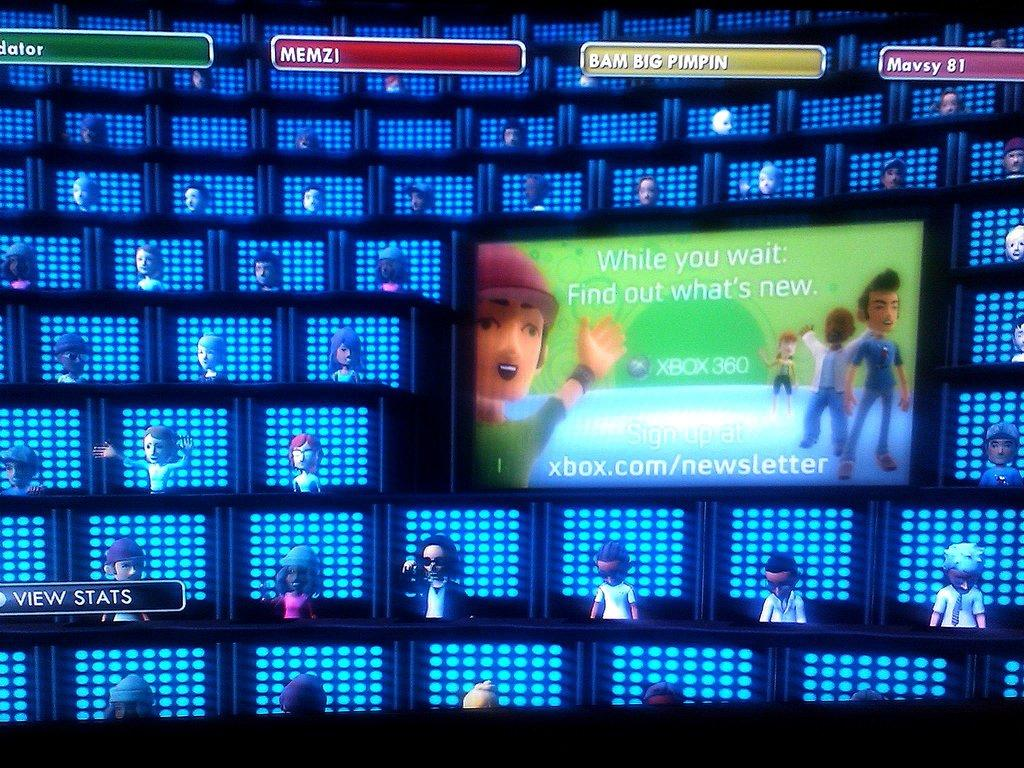<image>
Offer a succinct explanation of the picture presented. Appears to be a video game screen with players Bam Big Pimpin and Memzi among others. 